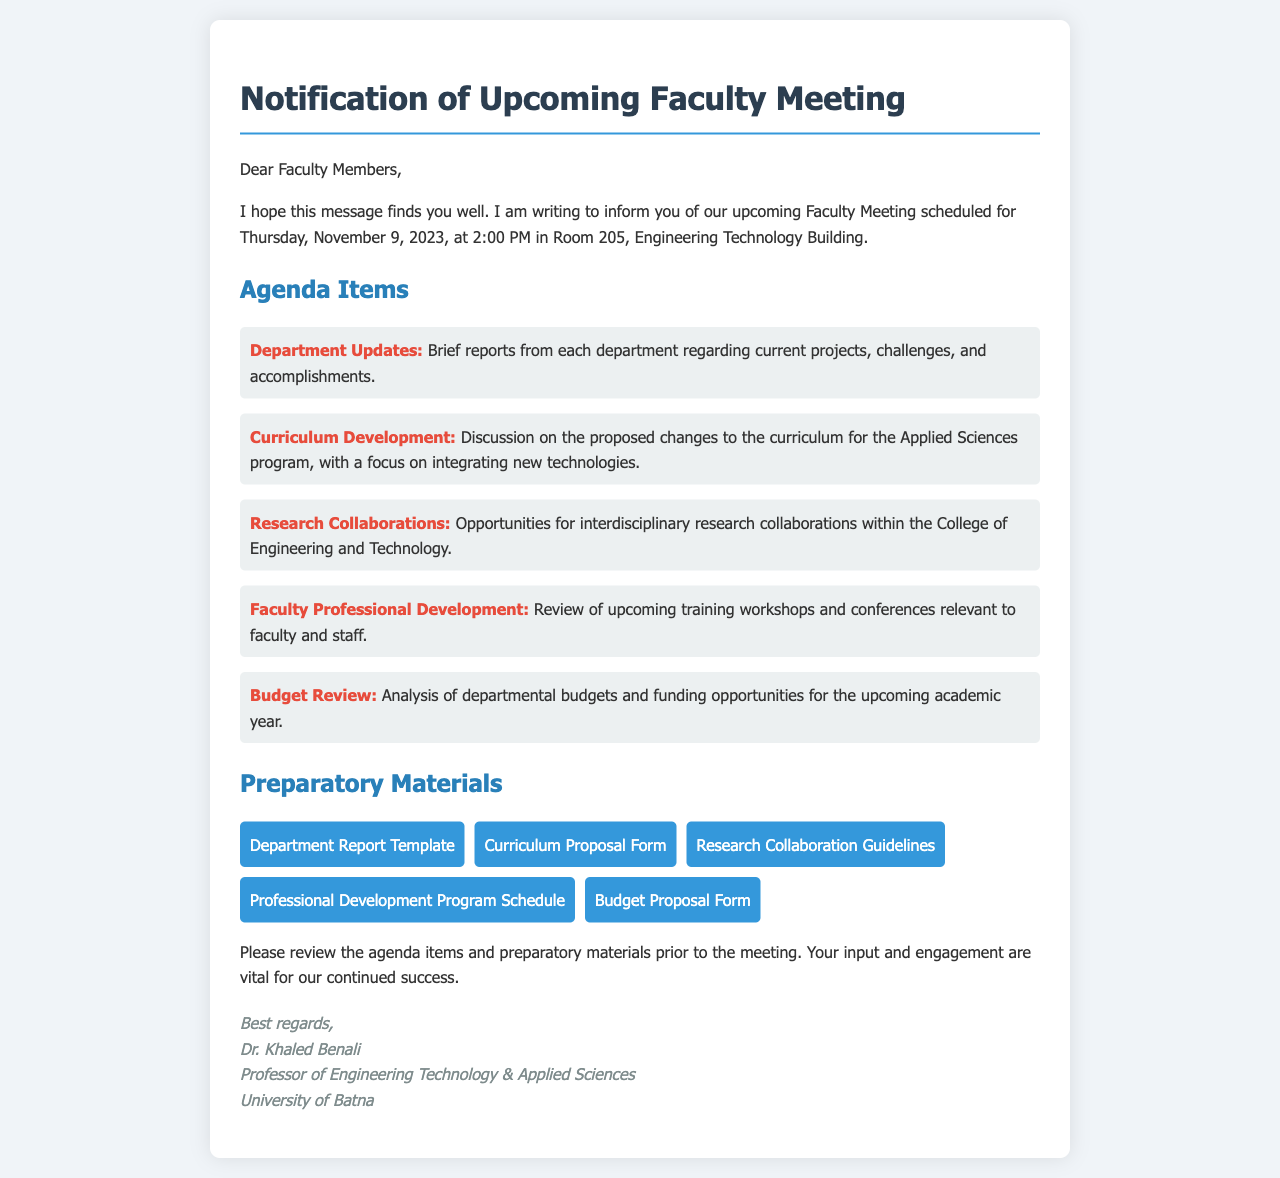What is the date of the upcoming faculty meeting? The date is specified in the document as Thursday, November 9, 2023.
Answer: Thursday, November 9, 2023 What room will the meeting take place in? The document states that the meeting will be held in Room 205, Engineering Technology Building.
Answer: Room 205 Who is the sender of the notification? The sender's name and title are mentioned in the signature section of the document, indicating who is notifying the faculty.
Answer: Dr. Khaled Benali How many agenda items are listed in the document? The document outlines five distinct agenda items for discussion during the meeting.
Answer: Five What is one of the topics to be discussed regarding department updates? The document specifies that updates include current projects, challenges, and accomplishments from each department.
Answer: Current projects What type of document is linked for the budget proposal? The preparatory materials include a document type related to budget proposals which indicates its nature.
Answer: Budget Proposal Form What is the focus of the curriculum development discussion? The document reveals that the focus will be on integrating new technologies into the curriculum for the Applied Sciences program.
Answer: Integrating new technologies Why is faculty input important for the meeting? The document highlights the significance of faculty engagement for the success of the department during the meeting.
Answer: Vital for our continued success What is one of the preparatory materials provided for meeting attendees? Among the links provided, the document identifies several preparatory materials that attendees need to review before the meeting.
Answer: Department Report Template 